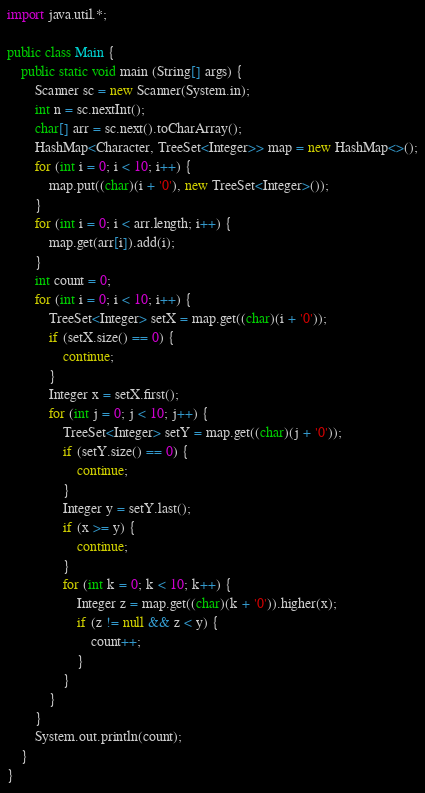<code> <loc_0><loc_0><loc_500><loc_500><_Java_>import java.util.*;

public class Main {
	public static void main (String[] args) {
		Scanner sc = new Scanner(System.in);
		int n = sc.nextInt();
		char[] arr = sc.next().toCharArray();
		HashMap<Character, TreeSet<Integer>> map = new HashMap<>();
		for (int i = 0; i < 10; i++) {
		    map.put((char)(i + '0'), new TreeSet<Integer>());
		}
		for (int i = 0; i < arr.length; i++) {
		    map.get(arr[i]).add(i);
		}
		int count = 0;
		for (int i = 0; i < 10; i++) {
		    TreeSet<Integer> setX = map.get((char)(i + '0'));
		    if (setX.size() == 0) {
		        continue;
		    }
		    Integer x = setX.first();
		    for (int j = 0; j < 10; j++) {
		        TreeSet<Integer> setY = map.get((char)(j + '0'));
		        if (setY.size() == 0) {
		            continue;
		        }
		        Integer y = setY.last();
		        if (x >= y) {
		            continue;
		        }
		        for (int k = 0; k < 10; k++) {
		            Integer z = map.get((char)(k + '0')).higher(x);
		            if (z != null && z < y) {
		                count++;
		            }
		        }
		    }
		}
		System.out.println(count);
	}
}
</code> 